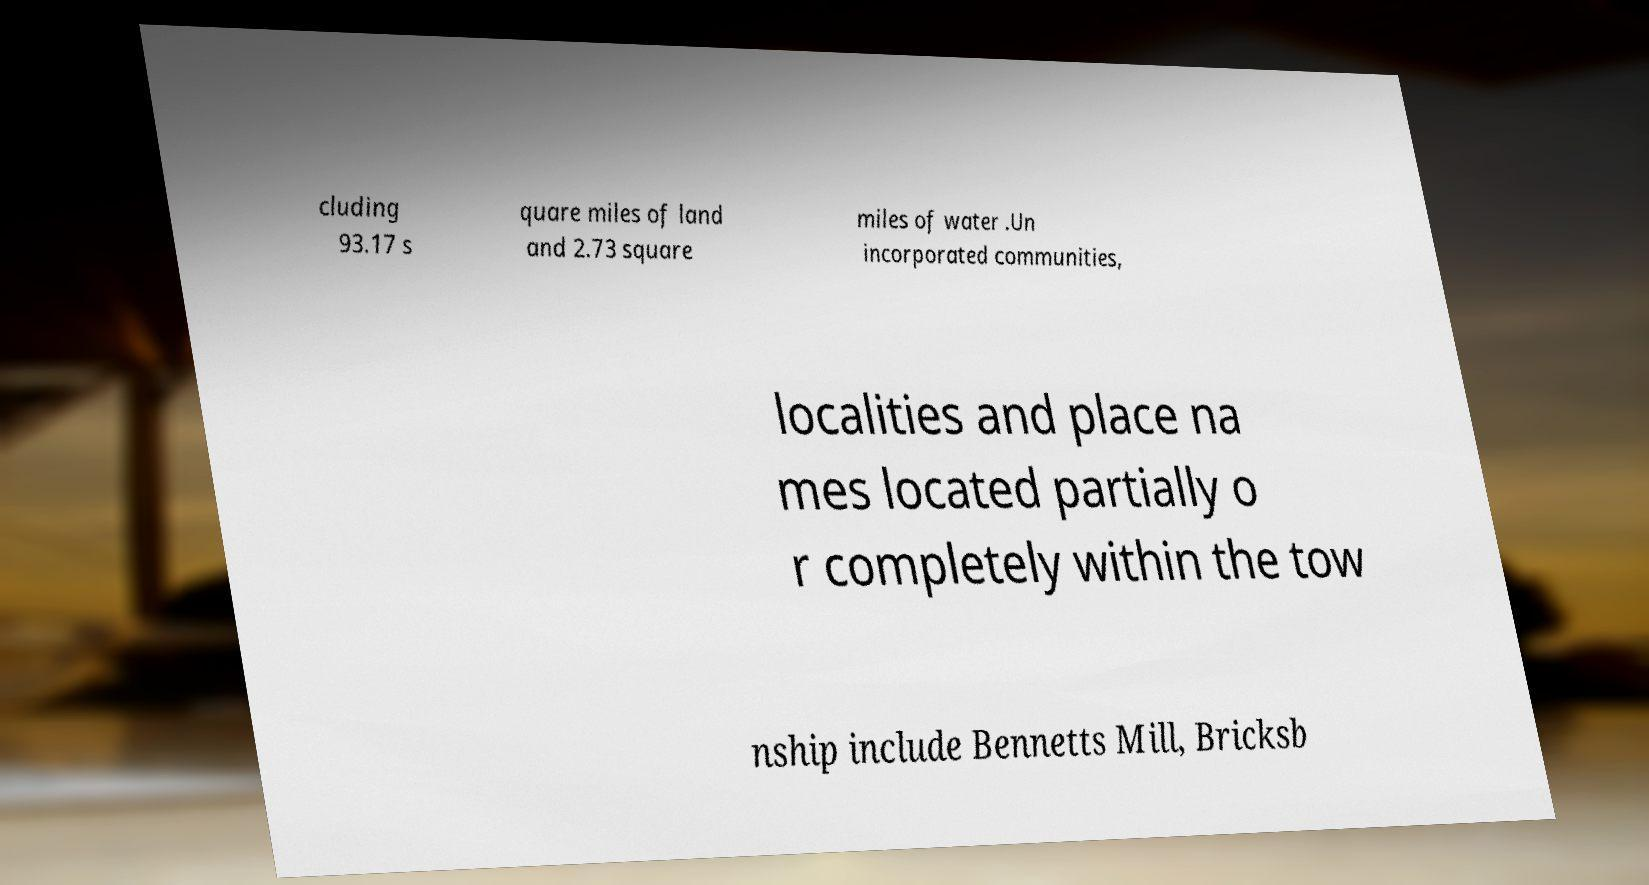Can you read and provide the text displayed in the image?This photo seems to have some interesting text. Can you extract and type it out for me? cluding 93.17 s quare miles of land and 2.73 square miles of water .Un incorporated communities, localities and place na mes located partially o r completely within the tow nship include Bennetts Mill, Bricksb 